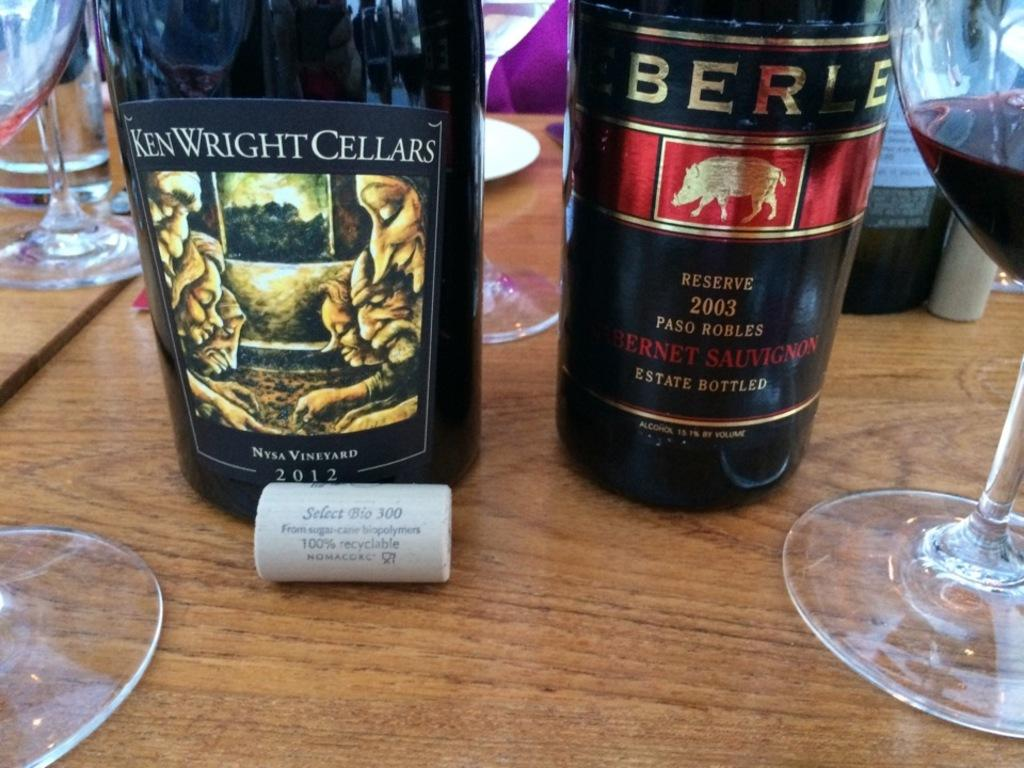<image>
Provide a brief description of the given image. A bottle is labeled Ken Wright Cellars.and is on a table next to another bottle. 